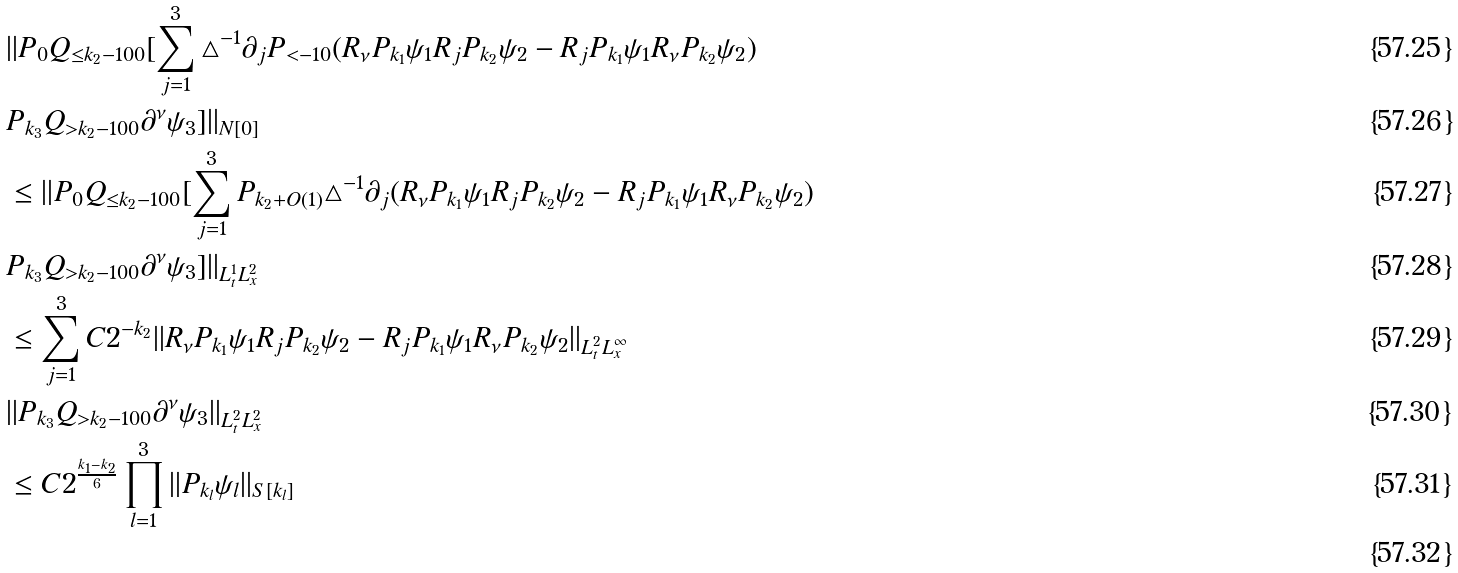<formula> <loc_0><loc_0><loc_500><loc_500>& | | P _ { 0 } Q _ { \leq k _ { 2 } - 1 0 0 } [ \sum _ { j = 1 } ^ { 3 } \triangle ^ { - 1 } \partial _ { j } P _ { < - 1 0 } ( R _ { \nu } P _ { k _ { 1 } } \psi _ { 1 } R _ { j } P _ { k _ { 2 } } \psi _ { 2 } - R _ { j } P _ { k _ { 1 } } \psi _ { 1 } R _ { \nu } P _ { k _ { 2 } } \psi _ { 2 } ) \\ & P _ { k _ { 3 } } Q _ { > k _ { 2 } - 1 0 0 } \partial ^ { \nu } \psi _ { 3 } ] | | _ { N [ 0 ] } \\ & \leq | | P _ { 0 } Q _ { \leq k _ { 2 } - 1 0 0 } [ \sum _ { j = 1 } ^ { 3 } P _ { k _ { 2 } + O ( 1 ) } \triangle ^ { - 1 } \partial _ { j } ( R _ { \nu } P _ { k _ { 1 } } \psi _ { 1 } R _ { j } P _ { k _ { 2 } } \psi _ { 2 } - R _ { j } P _ { k _ { 1 } } \psi _ { 1 } R _ { \nu } P _ { k _ { 2 } } \psi _ { 2 } ) \\ & P _ { k _ { 3 } } Q _ { > k _ { 2 } - 1 0 0 } \partial ^ { \nu } \psi _ { 3 } ] | | _ { L _ { t } ^ { 1 } L _ { x } ^ { 2 } } \\ & \leq \sum _ { j = 1 } ^ { 3 } C 2 ^ { - k _ { 2 } } | | R _ { \nu } P _ { k _ { 1 } } \psi _ { 1 } R _ { j } P _ { k _ { 2 } } \psi _ { 2 } - R _ { j } P _ { k _ { 1 } } \psi _ { 1 } R _ { \nu } P _ { k _ { 2 } } \psi _ { 2 } | | _ { L _ { t } ^ { 2 } L _ { x } ^ { \infty } } \\ & | | P _ { k _ { 3 } } Q _ { > k _ { 2 } - 1 0 0 } \partial ^ { \nu } \psi _ { 3 } | | _ { L _ { t } ^ { 2 } L _ { x } ^ { 2 } } \\ & \leq C 2 ^ { \frac { k _ { 1 } - k _ { 2 } } { 6 } } \prod _ { l = 1 } ^ { 3 } | | P _ { k _ { l } } \psi _ { l } | | _ { S [ k _ { l } ] } \\</formula> 